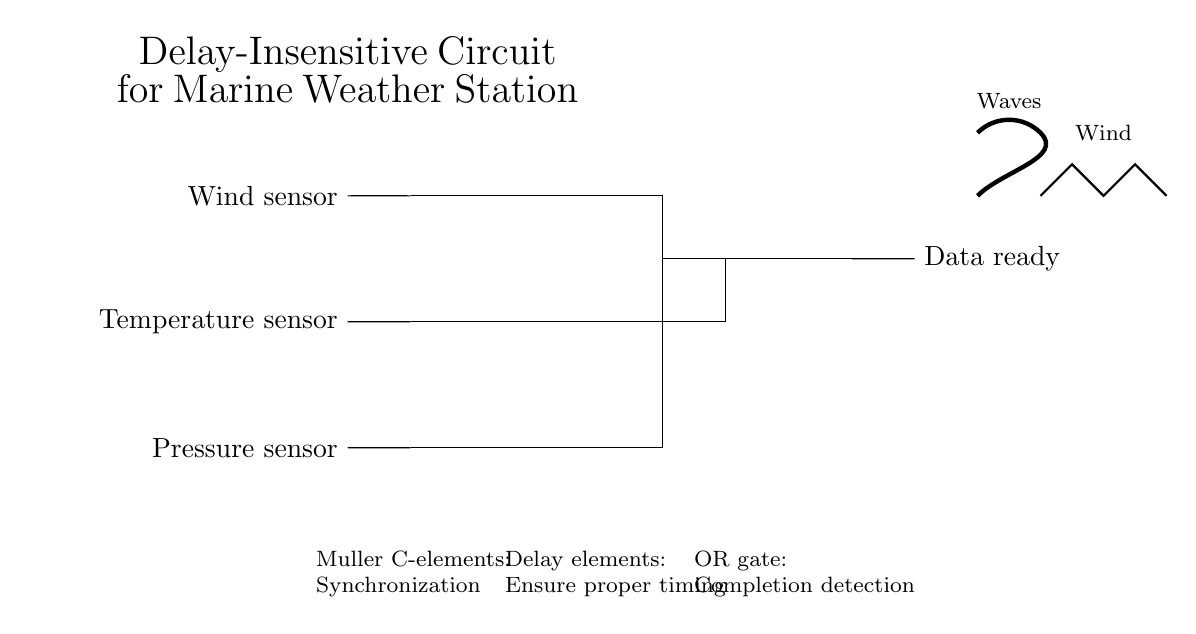What types of sensors are input to the circuit? The circuit diagram shows three sensors connected as inputs: a wind sensor, a temperature sensor, and a pressure sensor. Each is labeled on the left and connected to the inputs of the Muller C-elements.
Answer: wind, temperature, pressure How many Muller C-elements are used in the circuit? The diagram shows three Muller C-elements, one for each sensor input. They are positioned in a vertical line, each receiving inputs from the corresponding sensors.
Answer: three What is the function of the NOT gates in the circuit? Each NOT gate is used after the Muller C-elements to invert the signals before they are sent to the completion detection stage. This ensures that the correct timing and signal synchronization are maintained in the circuit.
Answer: signal inversion Describe the final output of the circuit. The output of the circuit is labeled as "Data ready," indicating that the circuit processes the inputs and generates this output signal once the data is complete and synchronized.
Answer: Data ready What type of logic gate is used for completion detection? The circuit uses an OR gate for completion detection. The OR gate combines signals from the inverted outputs of the Muller C-elements to determine if the necessary conditions are met for completing the data processing.
Answer: OR gate Why are delay elements included in this circuit? Delay elements are included to ensure that signals are synchronized properly, preventing any timing issues that could arise due to the asynchronous nature of the circuit. By delaying signals, the circuit can maintain correct operation and output signals in a timely manner.
Answer: synchronization What role does the OR gate play in the overall circuit operation? The OR gate completes the process by detecting when any of the inputs from the delay elements indicate that data is ready. It consolidates multiple signals to produce a single output, ensuring that the circuit provides a clear completion indication.
Answer: completion detection 